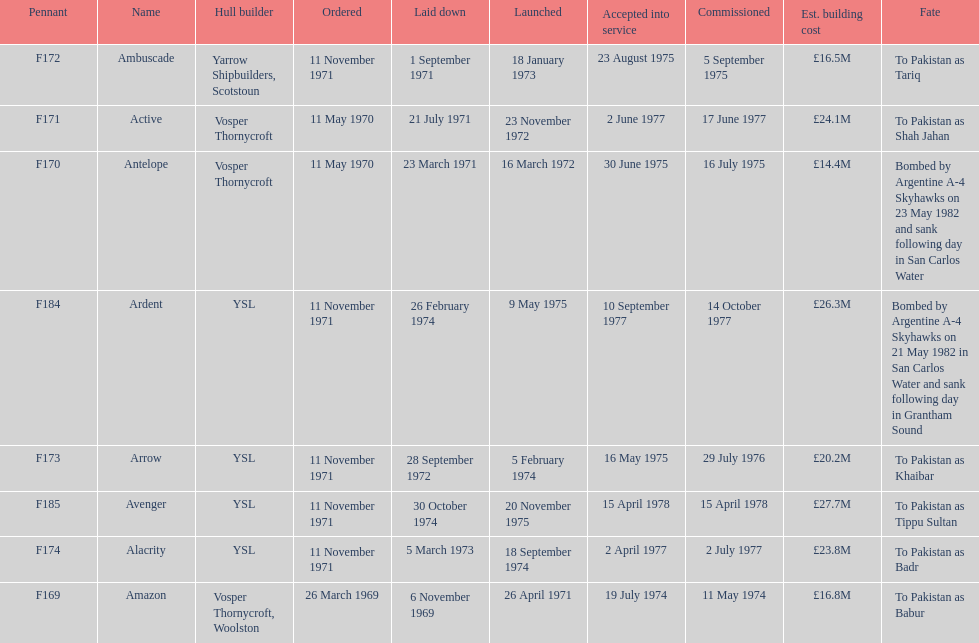How many boats costed less than £20m to build? 3. 